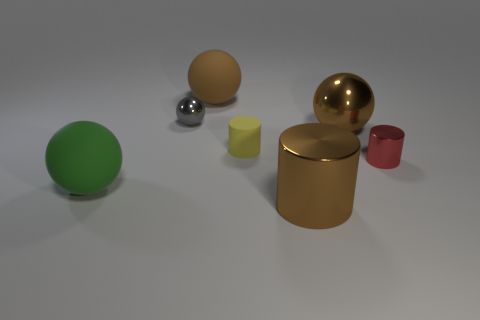How big is the yellow cylinder right of the rubber ball that is in front of the big rubber ball to the right of the green matte object?
Your answer should be compact. Small. There is a rubber object that is to the right of the big rubber thing that is behind the red metallic cylinder; what size is it?
Offer a very short reply. Small. There is a brown object to the left of the brown metallic cylinder; how big is it?
Provide a succinct answer. Large. Is the color of the large metallic cylinder the same as the matte sphere that is behind the green rubber thing?
Provide a succinct answer. Yes. Is there a sphere of the same color as the big cylinder?
Your answer should be compact. Yes. Is the tiny red object made of the same material as the big brown cylinder that is on the right side of the yellow matte object?
Offer a very short reply. Yes. How many small objects are either brown things or spheres?
Your answer should be compact. 1. There is another ball that is the same color as the large shiny ball; what is its material?
Provide a succinct answer. Rubber. Are there fewer green matte spheres than large yellow metallic cylinders?
Make the answer very short. No. There is a matte thing behind the large metal ball; is it the same size as the brown sphere that is on the right side of the big metal cylinder?
Make the answer very short. Yes. 